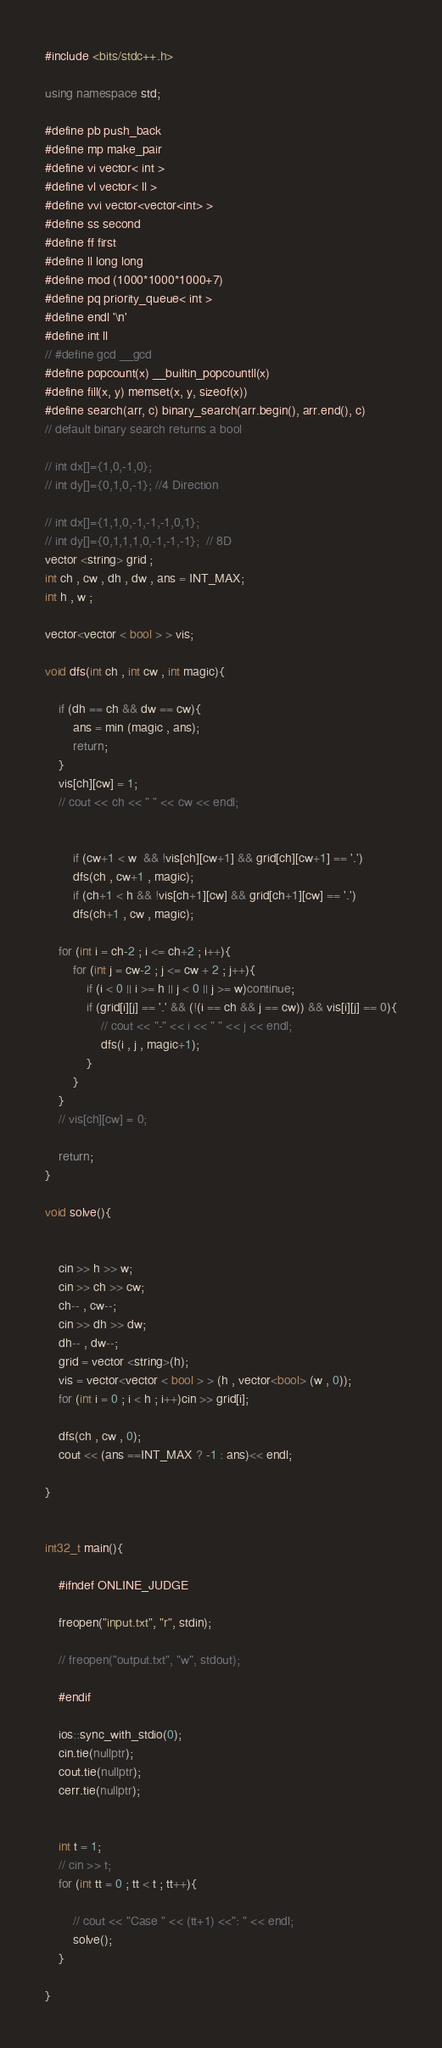Convert code to text. <code><loc_0><loc_0><loc_500><loc_500><_C++_>#include <bits/stdc++.h>
 
using namespace std;
 
#define pb push_back
#define mp make_pair
#define vi vector< int >
#define vl vector< ll >
#define vvi vector<vector<int> >
#define ss second
#define ff first
#define ll long long
#define mod (1000*1000*1000+7)
#define pq priority_queue< int >
#define endl '\n'
#define int ll
// #define gcd __gcd
#define popcount(x) __builtin_popcountll(x)
#define fill(x, y) memset(x, y, sizeof(x))
#define search(arr, c) binary_search(arr.begin(), arr.end(), c)
// default binary search returns a bool
 
// int dx[]={1,0,-1,0}; 
// int dy[]={0,1,0,-1}; //4 Direction 
 
// int dx[]={1,1,0,-1,-1,-1,0,1}; 
// int dy[]={0,1,1,1,0,-1,-1,-1};  // 8D
vector <string> grid ;
int ch , cw , dh , dw , ans = INT_MAX;
int h , w ;

vector<vector < bool > > vis;

void dfs(int ch , int cw , int magic){

    if (dh == ch && dw == cw){
        ans = min (magic , ans);
        return;
    }
    vis[ch][cw] = 1;
    // cout << ch << " " << cw << endl;


        if (cw+1 < w  && !vis[ch][cw+1] && grid[ch][cw+1] == '.')
        dfs(ch , cw+1 , magic);
        if (ch+1 < h && !vis[ch+1][cw] && grid[ch+1][cw] == '.')
        dfs(ch+1 , cw , magic);
    
    for (int i = ch-2 ; i <= ch+2 ; i++){
        for (int j = cw-2 ; j <= cw + 2 ; j++){
            if (i < 0 || i >= h || j < 0 || j >= w)continue;
            if (grid[i][j] == '.' && (!(i == ch && j == cw)) && vis[i][j] == 0){
                // cout << "-" << i << " " << j << endl;
                dfs(i , j , magic+1);
            }
        }
    }
    // vis[ch][cw] = 0;

    return;
}

void solve(){

    
    cin >> h >> w;
    cin >> ch >> cw;
    ch-- , cw--;
    cin >> dh >> dw;
    dh-- , dw--;
    grid = vector <string>(h);
    vis = vector<vector < bool > > (h , vector<bool> (w , 0));
    for (int i = 0 ; i < h ; i++)cin >> grid[i];

    dfs(ch , cw , 0);
    cout << (ans ==INT_MAX ? -1 : ans)<< endl;

}

 
int32_t main(){

    #ifndef ONLINE_JUDGE 
  
    freopen("input.txt", "r", stdin); 
  
    // freopen("output.txt", "w", stdout); 
  
    #endif 
 
    ios::sync_with_stdio(0);
    cin.tie(nullptr);
    cout.tie(nullptr);
    cerr.tie(nullptr);
 
 
    int t = 1;
    // cin >> t;
    for (int tt = 0 ; tt < t ; tt++){
        
        // cout << "Case " << (tt+1) <<": " << endl;
        solve();
    }
    
}</code> 